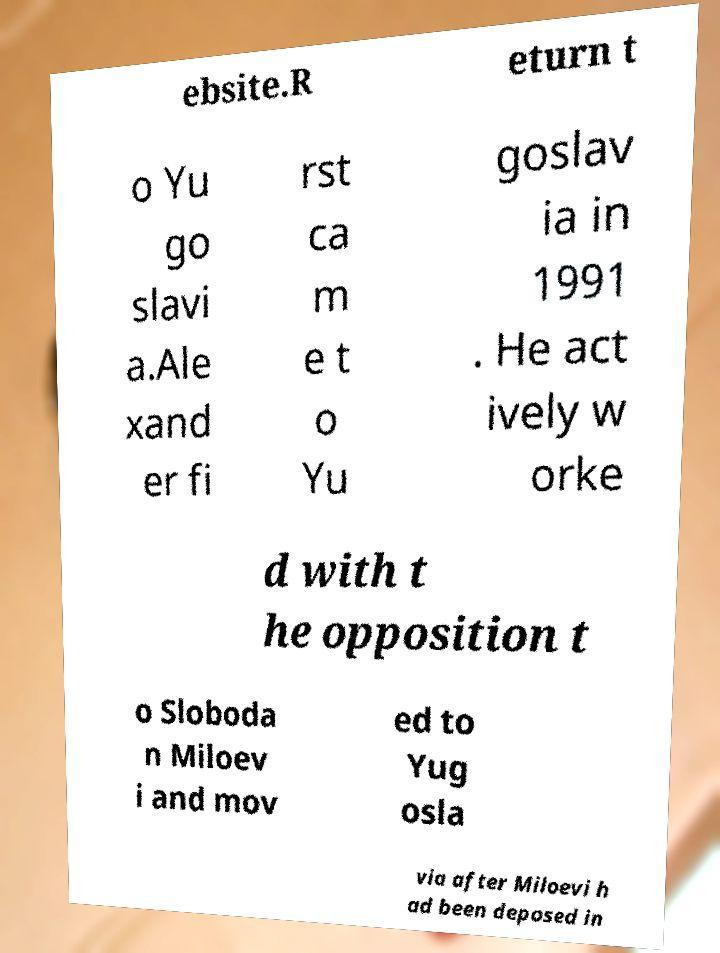I need the written content from this picture converted into text. Can you do that? ebsite.R eturn t o Yu go slavi a.Ale xand er fi rst ca m e t o Yu goslav ia in 1991 . He act ively w orke d with t he opposition t o Sloboda n Miloev i and mov ed to Yug osla via after Miloevi h ad been deposed in 